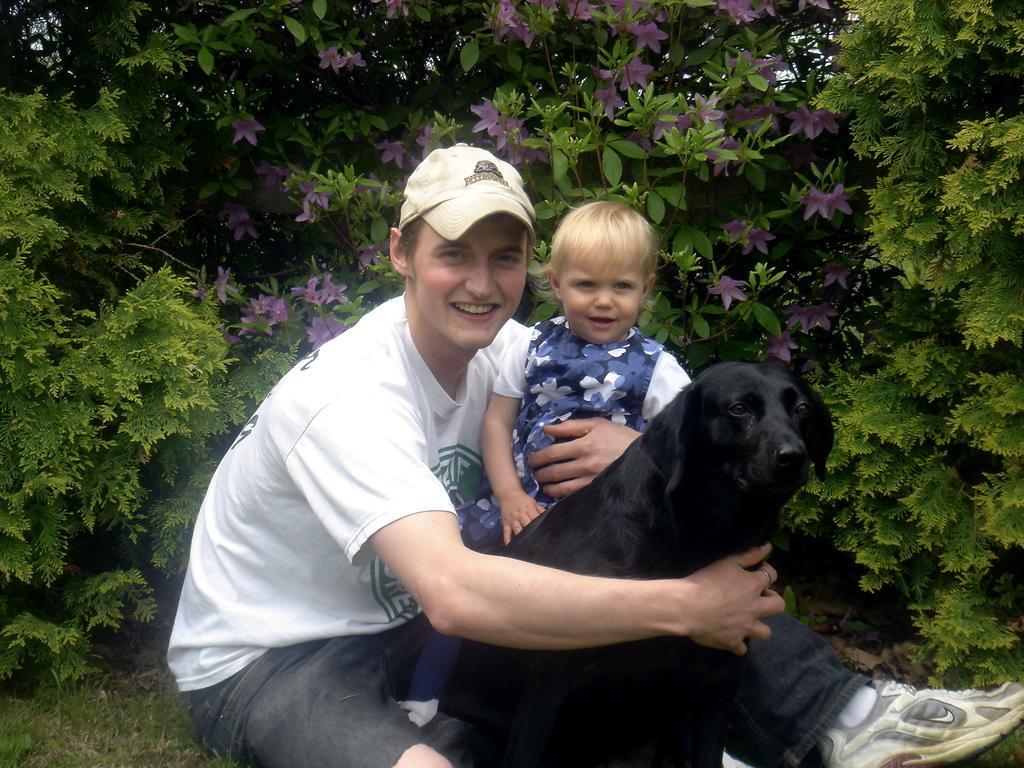In one or two sentences, can you explain what this image depicts? In this image I can see two people and the dog. These two people are wearing the white, blue and black color dresses. I can see one person with the cap and the dog is in black color. In the background I can see the purple color flowers to the plants. 